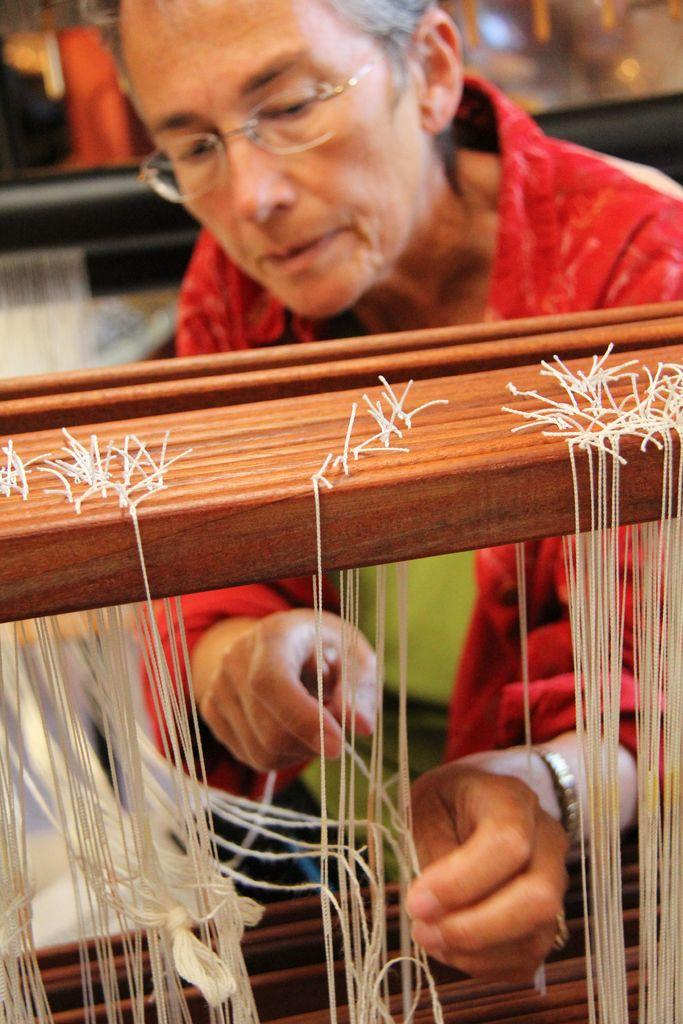Who is present in the image? There is a woman in the picture. What is the woman wearing in the image? The woman is wearing spectacles. What can be seen in the background of the image? There are threads visible in the image, and it appears to be a hand weaving machine. What type of society does the owl belong to in the image? There is no owl present in the image, so it is not possible to determine the type of society it might belong to. 